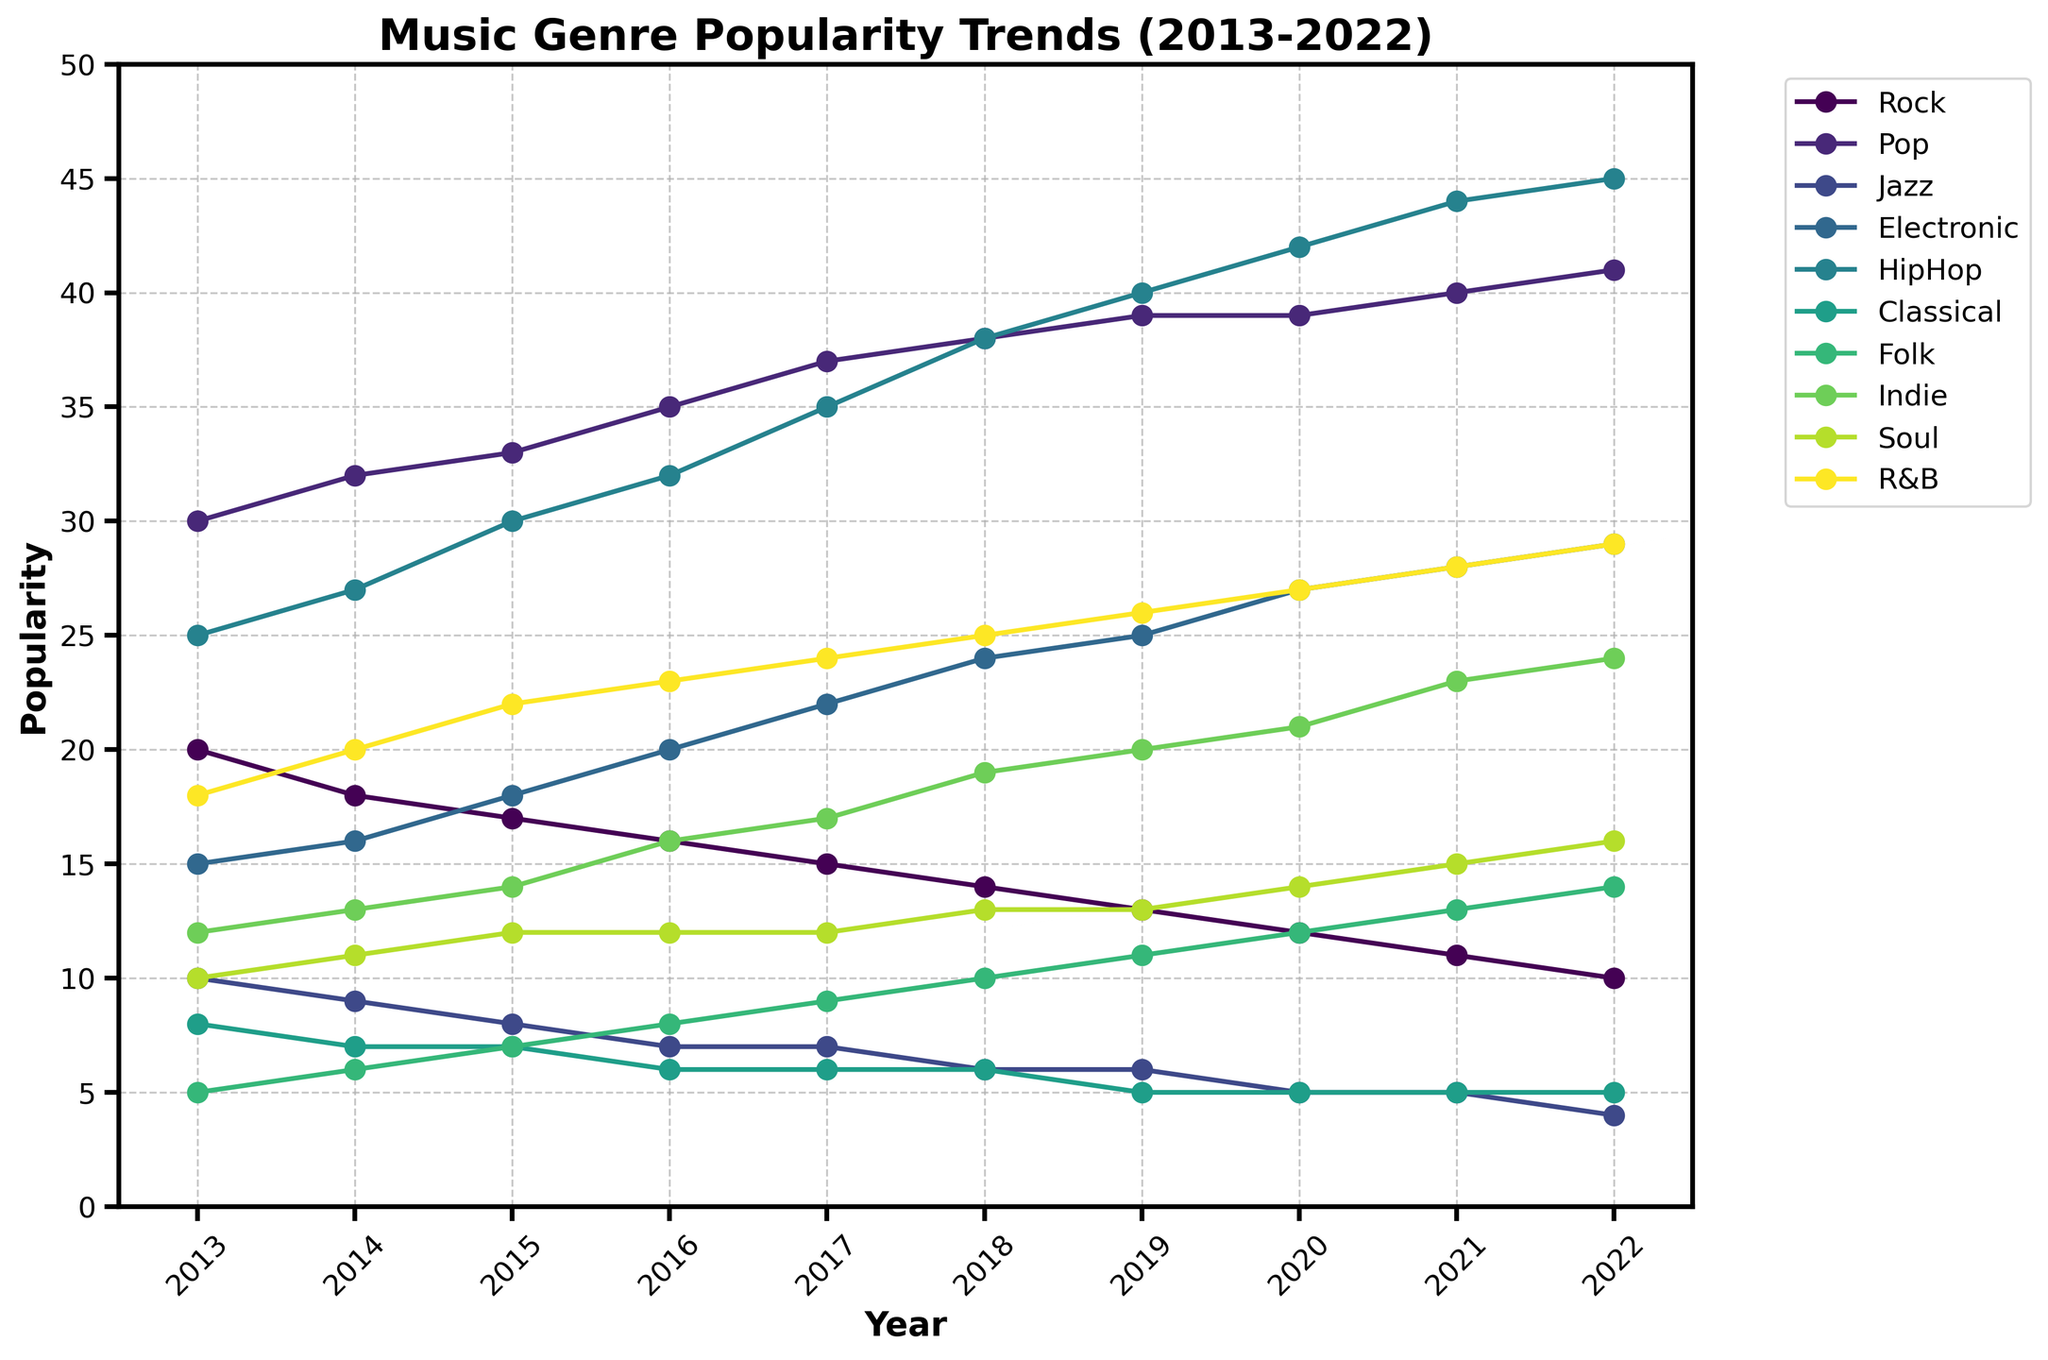What is the general trend for Rock music's popularity over the past decade? The popularity of Rock music decreased from 20 in 2013 to 10 in 2022. By examining the line representing Rock music on the plot, we can see a steady decline in its popularity over the years.
Answer: Declining Which music genre had the highest popularity in 2022? In 2022, the Pop music genre had the highest popularity at 41, as indicated by the highest point on the chart corresponding to the year 2022.
Answer: Pop How did the popularity of Electronic music change from 2013 to 2022? The popularity of Electronic music increased from 15 in 2013 to 29 in 2022. By looking at the plot, the line representing Electronic music shows a clear upward trend.
Answer: Increased What was the popularity of Classical music in 2017? In 2017, the popularity of Classical music was 6. This can be identified by looking at the intersection of the Classical music line with the year 2017 on the x-axis.
Answer: 6 Compare the popularity trends of Folk and Indie music. Which genre saw a higher increase? Folk music increased from 5 to 14, a change of 9. Indie music increased from 12 to 24, a change of 12. Thus, Indie music saw a higher increase over the decade.
Answer: Indie What was the average popularity of HipHop music from 2013 to 2022? The popularity values for HipHop music are [25, 27, 30, 32, 35, 38, 40, 42, 44, 45]. Summing these gives 358. Dividing by 10 years gives an average of 35.8.
Answer: 35.8 Which genre had a consistently increasing trend over the entire period? Pop music shows a consistently increasing trend from 30 in 2013 to 41 in 2022 without any dips or decreases.
Answer: Pop In which year did Soul music reach its highest popularity? Soul music reached its highest popularity in 2022, with a value of 16, as seen by the peak point in the line representing Soul music.
Answer: 2022 